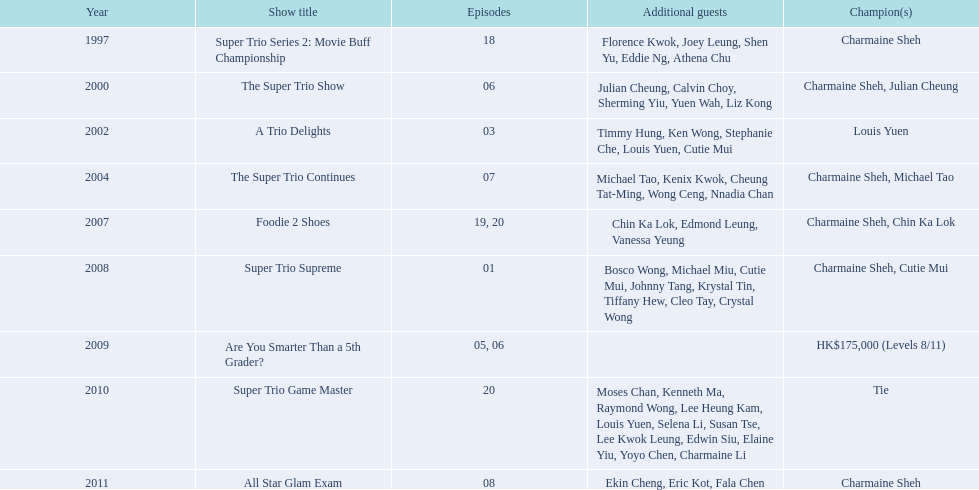How many episodes was charmaine sheh on in the variety show super trio 2: movie buff champions 18. 